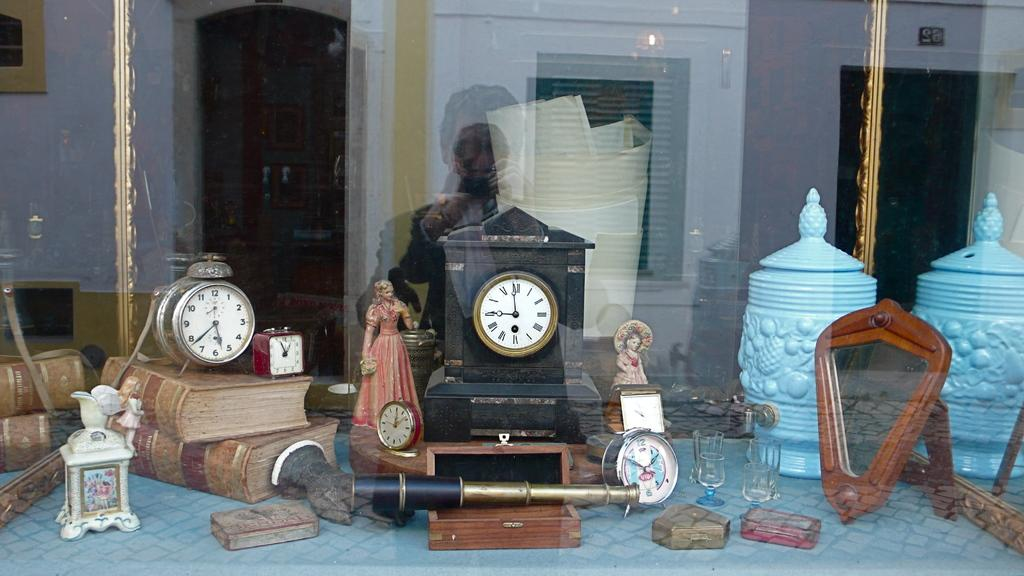<image>
Describe the image concisely. In a window display are several clocks, one of which is a small red one which shows the time as 12:55. 